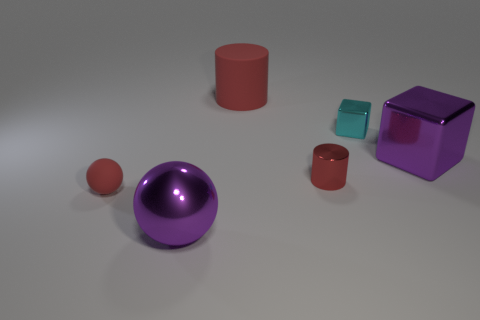How many small red objects have the same shape as the big rubber object?
Provide a succinct answer. 1. Is the number of large red matte things that are behind the purple sphere less than the number of small red metallic objects that are on the left side of the large red rubber object?
Offer a very short reply. No. What number of balls are to the left of the large metal sphere in front of the metallic cylinder?
Your answer should be compact. 1. Are any tiny red metal things visible?
Give a very brief answer. Yes. Is there another tiny object that has the same material as the tiny cyan object?
Your response must be concise. Yes. Is the number of tiny red things that are to the left of the large rubber thing greater than the number of small metal objects in front of the big purple block?
Make the answer very short. No. Is the size of the cyan thing the same as the purple metallic ball?
Your answer should be compact. No. What is the color of the large thing that is in front of the red rubber object to the left of the large sphere?
Offer a very short reply. Purple. What is the color of the small rubber ball?
Offer a very short reply. Red. Are there any shiny cylinders of the same color as the big block?
Ensure brevity in your answer.  No. 